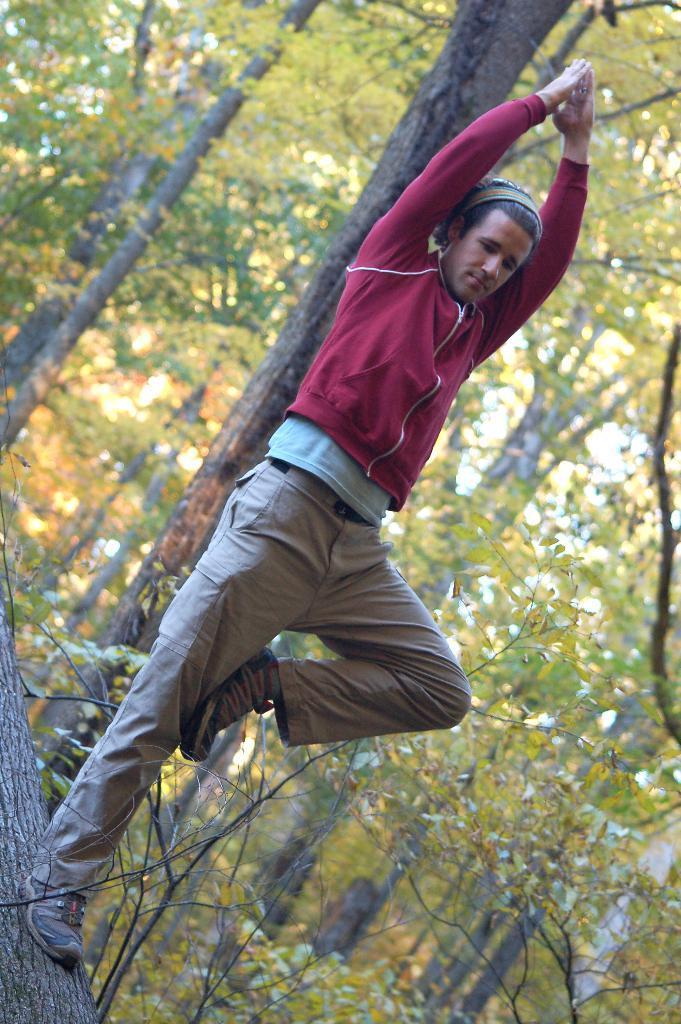Describe this image in one or two sentences. In the middle of the image we can see a man, he is standing and he wore a red color jacket, in the background we can see few trees. 